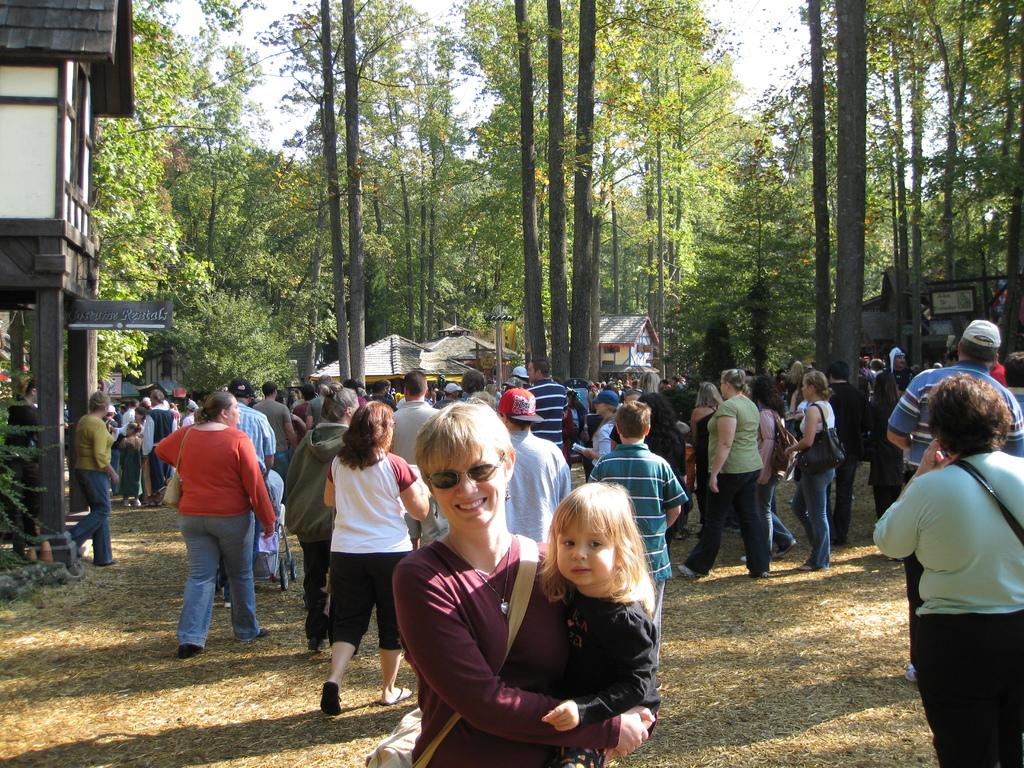Who or what can be seen in the image? There are people, houses, boards, trees, and a baby chair in the distance in the image. What is the woman doing in the image? The woman is carrying a baby in the image. What are some people wearing in the image? Some people are wearing bags in the image. What can be seen in the sky in the image? The sky is visible in the image. What type of magic is being performed by the people in the image? There is no magic being performed in the image; it features people, houses, boards, trees, and a baby chair in the distance. Is there a battle taking place in the image? No, there is no battle depicted in the image. 